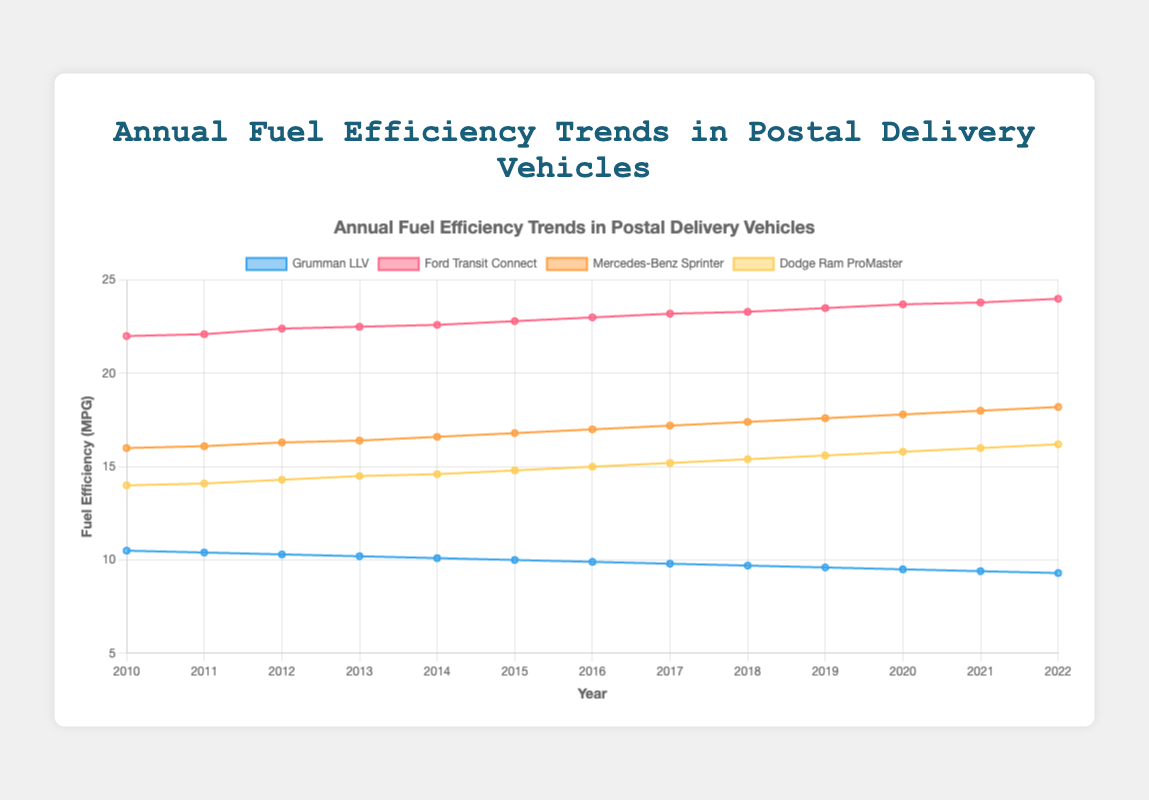Which vehicle had the highest fuel efficiency in 2010? To find the vehicle with the highest fuel efficiency, look at the data points on the plot for 2010. Compare the values for each vehicle.
Answer: Ford Transit Connect How did the fuel efficiency of the Grumman LLV change between 2010 and 2022? Find the data points for the Grumman LLV for the years 2010 and 2022. Calculate the difference between these values. The fuel efficiency decreased from 10.5 MPG in 2010 to 9.3 MPG in 2022.
Answer: It decreased by 1.2 MPG Which vehicle had consistent improvement in its fuel efficiency from 2010 to 2022? Examine the trend lines for each vehicle. Identify the one with a steadily increasing line from 2010 to 2022.
Answer: Ford Transit Connect Compare the fuel efficiency of the Mercedes-Benz Sprinter and the Dodge Ram ProMaster in 2016. Which one was more efficient? Look at the data points for both the Mercedes-Benz Sprinter and Dodge Ram ProMaster for the year 2016. Compare their values.
Answer: Mercedes-Benz Sprinter What is the difference in fuel efficiency between the most efficient and the least efficient vehicle in 2022? Find the data points for each vehicle in 2022. Identify the maximum and minimum values. Subtract the minimum value from the maximum value. The maximum is 24.0 MPG (Ford Transit Connect) and the minimum is 9.3 MPG (Grumman LLV), so the difference is 24.0 - 9.3.
Answer: 14.7 MPG What is the average fuel efficiency of the Ford Transit Connect from 2010 to 2022? Calculate the sum of the Ford Transit Connect's fuel efficiency values for each year and then divide by the number of years (13). The values sum to 293.4, so the average is 293.4 / 13.
Answer: 22.57 MPG In which year did the Dodge Ram ProMaster reach a fuel efficiency of 15.2 MPG? Check the data points for the Dodge Ram ProMaster across the years and find the year when the value is 15.2 MPG.
Answer: 2017 Which vehicle had the least change in fuel efficiency over the entire period? Calculate the difference between the 2010 and 2022 values for each vehicle and identify the smallest difference. The changes are 1.2 (Grumman LLV), 2.0 (Ford Transit Connect), 2.2 (Mercedes-Benz Sprinter), and 2.2 (Dodge Ram ProMaster).
Answer: Grumman LLV By how much did the fuel efficiency of the Mercedes-Benz Sprinter increase from 2010 to 2017? Calculate the difference between the Mercedes-Benz Sprinter's fuel efficiency in 2010 and 2017. The values are 16.0 MPG in 2010 and 17.2 MPG in 2017, so the difference is 17.2 - 16.0.
Answer: 1.2 MPG What year saw the highest fuel efficiency improvement for the Ford Transit Connect? Look for the largest increment between consecutive years for the Ford Transit Connect. The highest yearly increment is between 2010 and 2011 (0.1 MPG).
Answer: 2011 